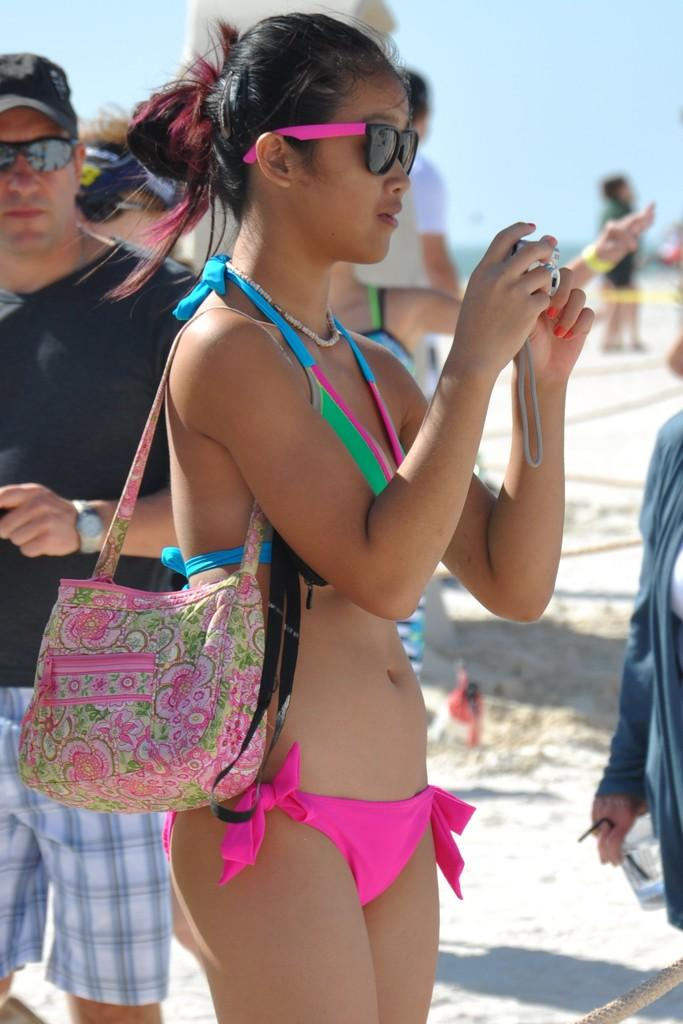What is the lady in the image wearing? The lady is wearing a bikini in the image. What accessory is the lady carrying? The lady is carrying a pink handbag. What is the lady holding in her hand? The lady is holding a camera in her hand. Can you describe the person in the image besides the lady? There is a person wearing a black shirt in the image. How many feet of yarn can be seen in the image? There is no yarn present in the image, so it is not possible to determine the length of any yarn. 